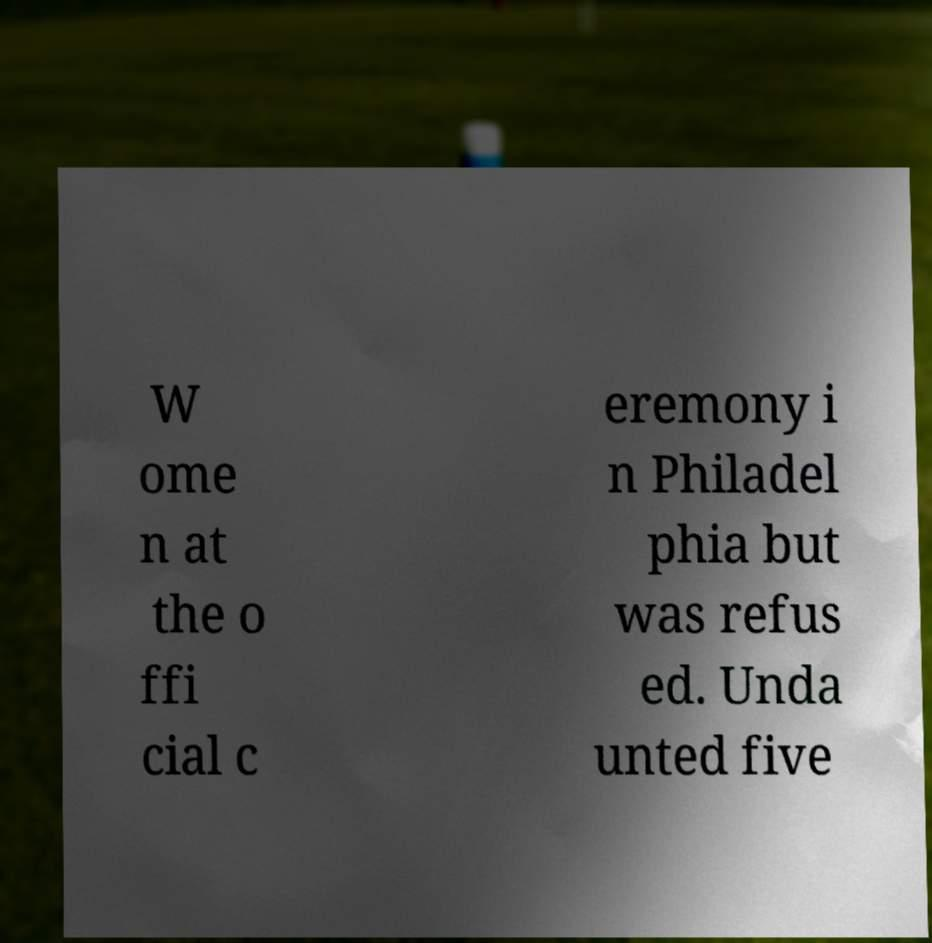Could you assist in decoding the text presented in this image and type it out clearly? W ome n at the o ffi cial c eremony i n Philadel phia but was refus ed. Unda unted five 